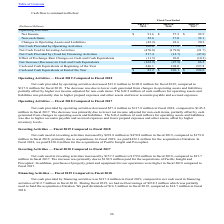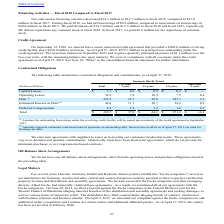According to Methode Electronics's financial document, How much did Net cash provided by operating activities decreased from fiscal 2019 to 2018? According to the financial document, $15.8 million. The relevant text states: "et cash provided by operating activities decreased $15.8 million to $102.0 million for fiscal 2019, compared to..." Also, What led to decrease in Net cash provided by operating activities? due to lower cash generated from changes in operating assets and liabilities, partially offset by higher net income adjusted for non-cash items.. The document states: "$117.8 million for fiscal 2018. The decrease was due to lower cash generated from changes in operating assets and liabilities, partially offset by hig..." Also, How much did Net cash provided by operating activities decreased from fiscal 2018 to 2017? According to the financial document, $27.4 million. The relevant text states: "et cash provided by operating activities decreased $27.4 million to $117.8 million in fiscal 2018, compared to $145.2..." Also, can you calculate: What is the change in Net Cash Provided by Operating Activities from Fiscal Year Ended April 28, 2018 to Fiscal Year Ended April 27, 2019? Based on the calculation: 102.0-117.8, the result is -15.8 (in millions). This is based on the information: "Net Cash Provided by Operating Activities 102.0 117.8 145.2 Net Cash Provided by Operating Activities 102.0 117.8 145.2..." The key data points involved are: 102.0, 117.8. Also, can you calculate: What is the change in Net Cash Used in Investing Activities from Fiscal Year Ended April 28, 2018 to Fiscal Year Ended April 27, 2019? Based on the calculation: -470.8-(-179.0), the result is -291.8 (in millions). This is based on the information: "Net Cash Used in Investing Activities (470.8) (179.0) (21.7) Net Cash Used in Investing Activities (470.8) (179.0) (21.7)..." The key data points involved are: 179.0, 470.8. Also, can you calculate: What is the change in Effect of Exchange Rate Changes on Cash and Cash Equivalents from Fiscal Year Ended April 28, 2018 to Fiscal Year Ended April 27, 2019? Based on the calculation: -11.5-26.0, the result is -37.5 (in millions). This is based on the information: "Rate Changes on Cash and Cash Equivalents (11.5) 26.0 (10.3) change Rate Changes on Cash and Cash Equivalents (11.5) 26.0 (10.3)..." The key data points involved are: 11.5, 26.0. 